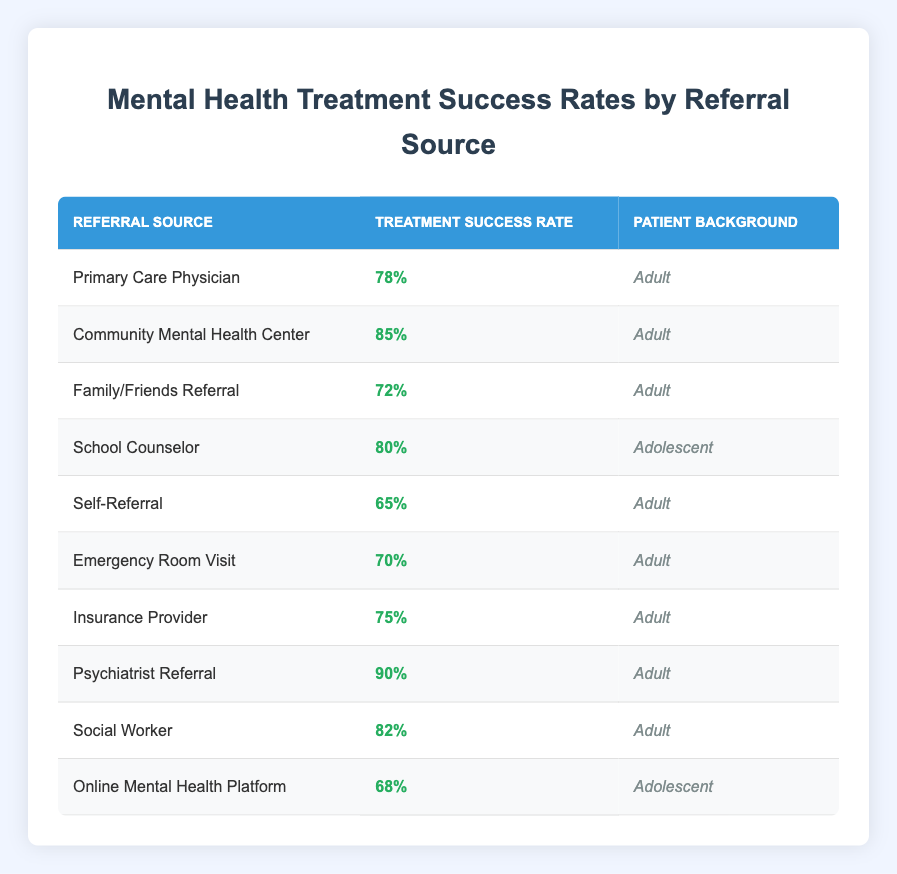What is the treatment success rate for the "Psychiatrist Referral"? The table shows that the treatment success rate for "Psychiatrist Referral" is listed under the corresponding row, which is 90%.
Answer: 90% Which referral source has the lowest treatment success rate among adults? By examining the treatment success rates listed for all adult referral sources, "Self-Referral" has the lowest value at 65%.
Answer: Self-Referral What is the average treatment success rate for adolescent patients? There are two adolescent sources: "School Counselor" with 80% and "Online Mental Health Platform" with 68%. Adding these gives 148%, and dividing by 2 (the number of sources) results in an average of 74%.
Answer: 74% Is the treatment success rate for "Community Mental Health Center" higher than that for "Emergency Room Visit"? Comparing the two values in the table, "Community Mental Health Center" is 85% and "Emergency Room Visit" is 70%, which confirms that 85% is greater than 70%.
Answer: Yes What referral source has the highest treatment success rate, and what is that rate? By checking the table for the highest value listed, "Psychiatrist Referral" appears with 90%, making it the highest source.
Answer: Psychiatrist Referral, 90% How does the treatment success rate of "Social Worker" compare to that of "Family/Friends Referral"? The "Social Worker" has a success rate of 82%, and "Family/Friends Referral" has 72%, which establishes that 82% is greater than 72%.
Answer: Social Worker is higher What is the difference in treatment success rates between the highest and lowest rates recorded? The highest rate is 90% from "Psychiatrist Referral", and the lowest is 65% from "Self-Referral". Calculating the difference gives us 90% - 65% = 25%.
Answer: 25% Which sources have treatment success rates above 75%? Inspecting the table, the sources that exceed 75% are "Community Mental Health Center" (85%), "Psychiatrist Referral" (90%), "Social Worker" (82%), and "Primary Care Physician" (78%).
Answer: Community Mental Health Center, Psychiatrist Referral, Social Worker, Primary Care Physician Is the treatment success rate for "Online Mental Health Platform" equal to or above 75%? The table lists "Online Mental Health Platform" with a success rate of 68%, which is below 75%, indicating it is not equal to or above that threshold.
Answer: No 